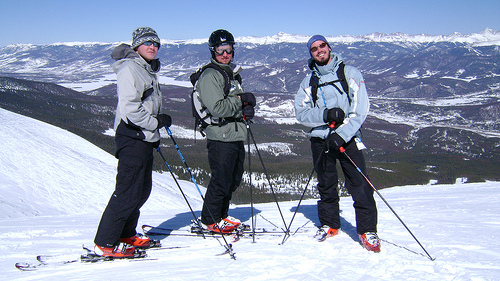How does the equipment used by the skiers appear to be suited for the conditions shown in the image? The equipment, including sturdy and brightly colored ski boots and sharply designed ski poles, appears highly functional and specifically designed for navigating the thick, powdery snow, providing both comfort and safety for the skiers. 